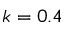<formula> <loc_0><loc_0><loc_500><loc_500>k = 0 . 4</formula> 